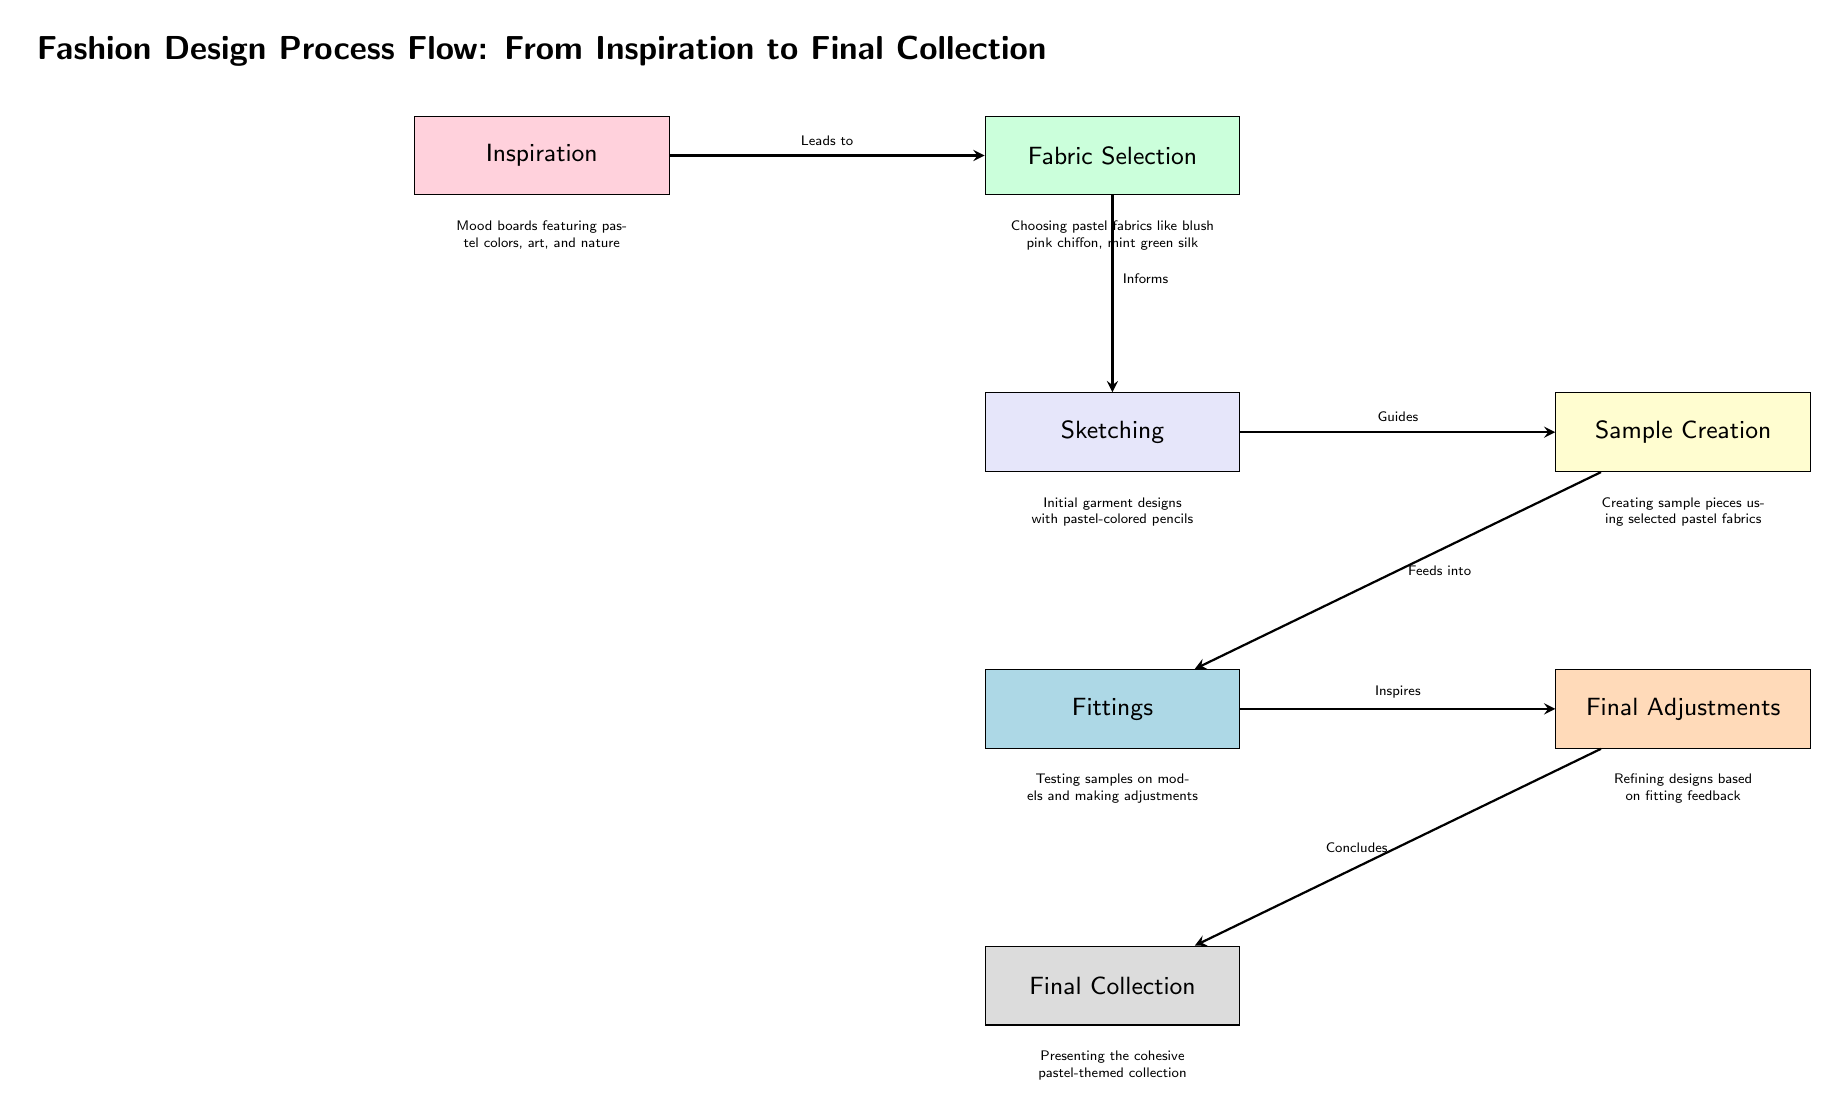What is the first step in the fashion design process? The diagram indicates that the first step, or node, is "Inspiration." This is directly shown at the top of the flowchart.
Answer: Inspiration How many main processes are depicted in the diagram? The diagram lists six main processes, which are nodes: Inspiration, Fabric Selection, Sketching, Sample Creation, Fittings, and Final Adjustments. Counting these processes gives a total of six.
Answer: 6 What color is associated with the Fabric Selection process? According to the diagram, Fabric Selection is colored pastel mint, as shown in the fill color of the corresponding node.
Answer: Pastel Mint Which process leads to Final Adjustments? The arrow stemming from the Fittings process indicates that it leads to Final Adjustments, showing the directional relationship between these nodes.
Answer: Fittings What is the description associated with the Sample Creation process? Below the Sample Creation node, the description reads "Creating sample pieces using selected pastel fabrics," which provides clarity on the activities involved in this stage.
Answer: Creating sample pieces using selected pastel fabrics What informs the Sketching process in the design flow? The diagram shows that the Fabric Selection process informs the Sketching process, as indicated by the arrow connecting these two nodes and the accompanying label "Informs."
Answer: Fabric Selection What is the final outcome of the fashion design process? The last node in the flow is labeled "Final Collection," which summarizes the ultimate goal of the entire design process.
Answer: Final Collection How does Inspiration relate to Fabric Selection in the flow? The diagram illustrates a direct relationship where Inspiration leads to Fabric Selection, evidenced by the arrow labeled "Leads to" connecting these two processes.
Answer: Leads to What stage involves testing samples on models? The Fittings process is described as the stage where samples are tested on models, which is indicated in the diagram under the corresponding node.
Answer: Fittings 